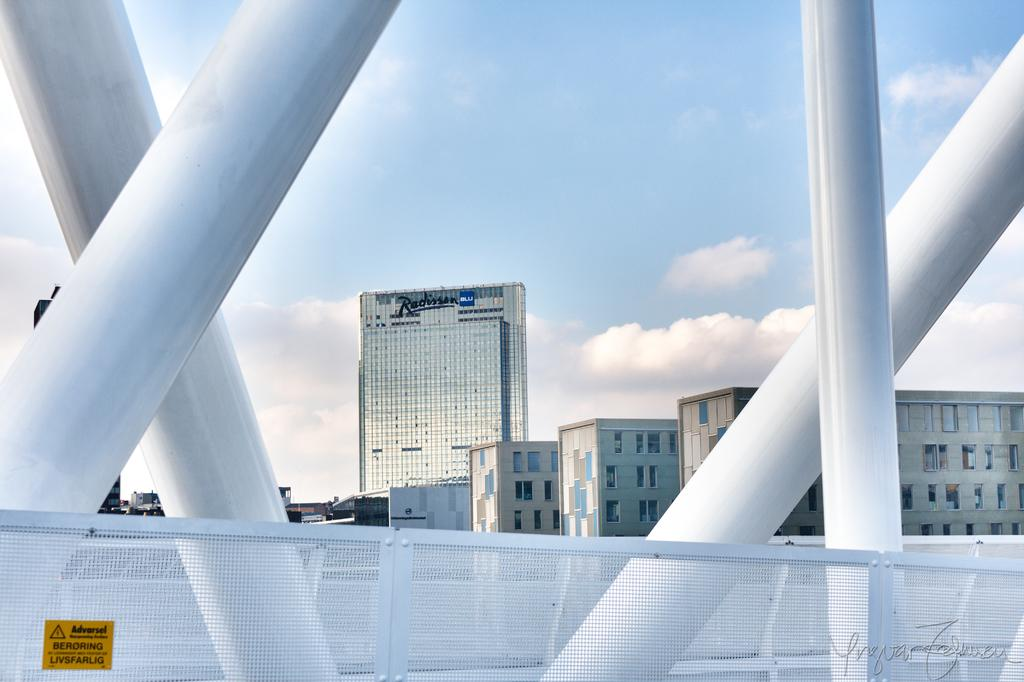Provide a one-sentence caption for the provided image. A fence on a bridge with a sticker giving an Adversel. 